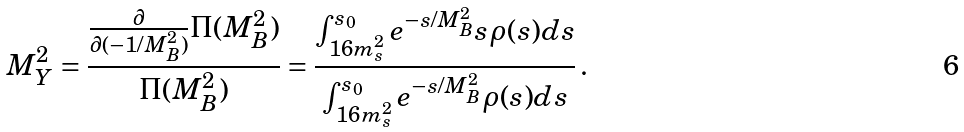<formula> <loc_0><loc_0><loc_500><loc_500>M ^ { 2 } _ { Y } = \frac { \frac { \partial } { \partial ( - 1 / M _ { B } ^ { 2 } ) } \Pi ( M _ { B } ^ { 2 } ) } { \Pi ( M _ { B } ^ { 2 } ) } = \frac { \int ^ { s _ { 0 } } _ { 1 6 m _ { s } ^ { 2 } } e ^ { - s / M _ { B } ^ { 2 } } s \rho ( s ) d s } { \int ^ { s _ { 0 } } _ { 1 6 m _ { s } ^ { 2 } } e ^ { - s / M _ { B } ^ { 2 } } \rho ( s ) d s } \, .</formula> 